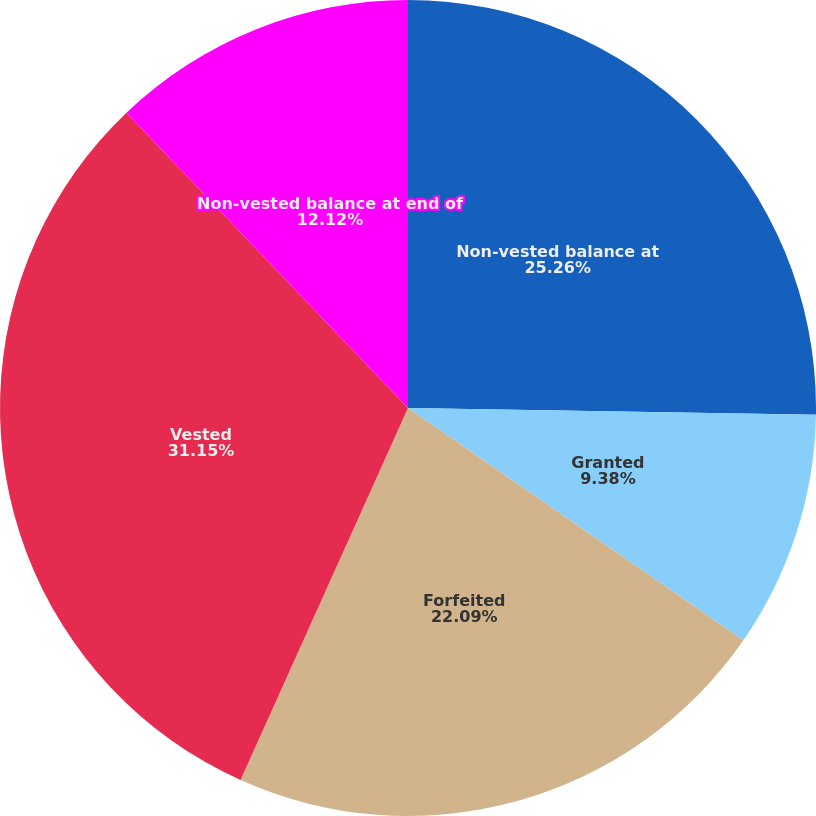Convert chart to OTSL. <chart><loc_0><loc_0><loc_500><loc_500><pie_chart><fcel>Non-vested balance at<fcel>Granted<fcel>Forfeited<fcel>Vested<fcel>Non-vested balance at end of<nl><fcel>25.26%<fcel>9.38%<fcel>22.09%<fcel>31.15%<fcel>12.12%<nl></chart> 